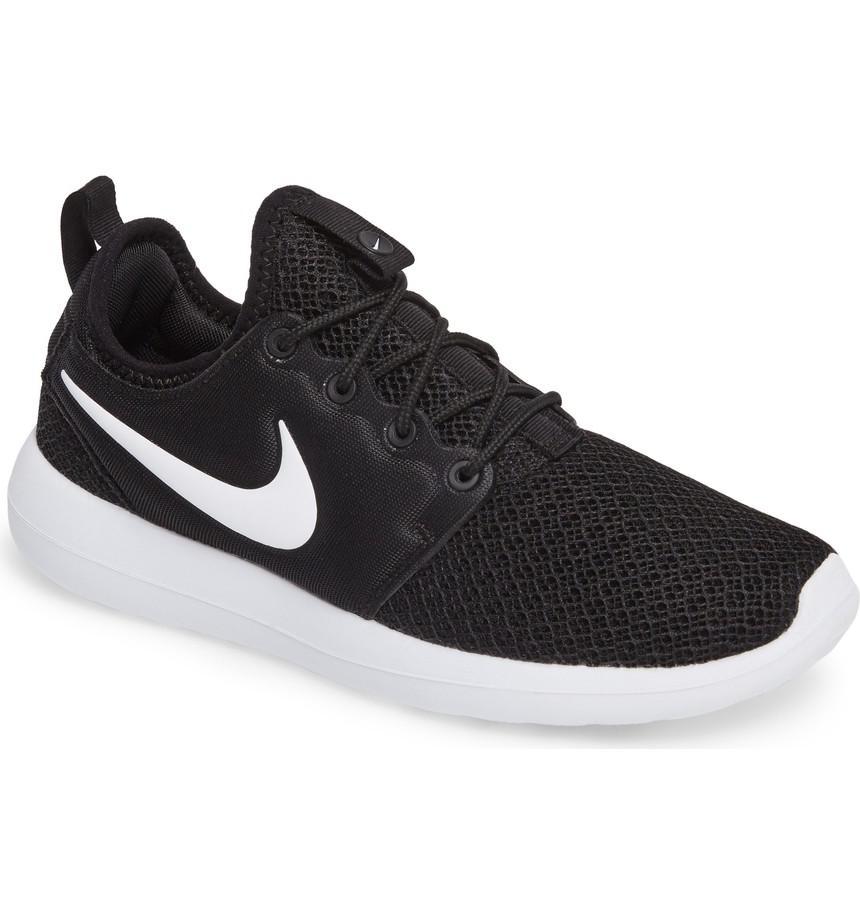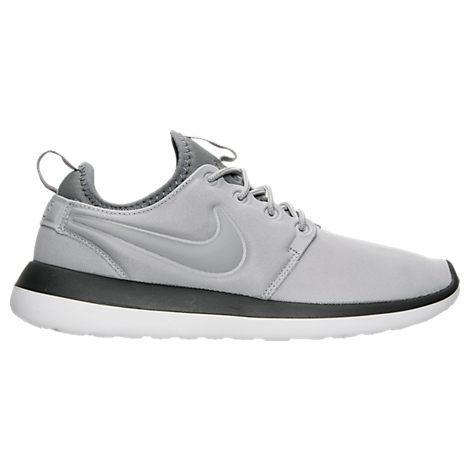The first image is the image on the left, the second image is the image on the right. Considering the images on both sides, is "Each set features shoes that are dramatically different in color or design." valid? Answer yes or no. Yes. The first image is the image on the left, the second image is the image on the right. Examine the images to the left and right. Is the description "Both shoes have a gray tongue." accurate? Answer yes or no. No. 